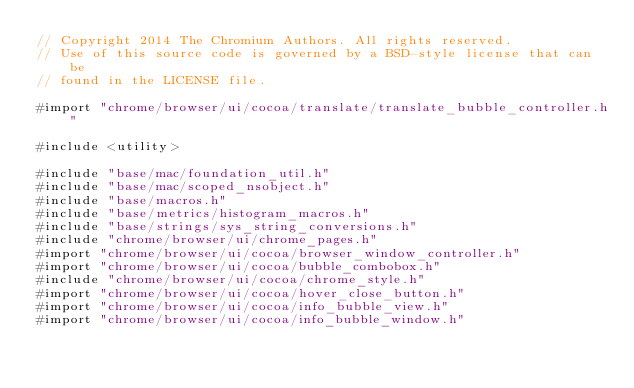<code> <loc_0><loc_0><loc_500><loc_500><_ObjectiveC_>// Copyright 2014 The Chromium Authors. All rights reserved.
// Use of this source code is governed by a BSD-style license that can be
// found in the LICENSE file.

#import "chrome/browser/ui/cocoa/translate/translate_bubble_controller.h"

#include <utility>

#include "base/mac/foundation_util.h"
#include "base/mac/scoped_nsobject.h"
#include "base/macros.h"
#include "base/metrics/histogram_macros.h"
#include "base/strings/sys_string_conversions.h"
#include "chrome/browser/ui/chrome_pages.h"
#import "chrome/browser/ui/cocoa/browser_window_controller.h"
#import "chrome/browser/ui/cocoa/bubble_combobox.h"
#include "chrome/browser/ui/cocoa/chrome_style.h"
#import "chrome/browser/ui/cocoa/hover_close_button.h"
#import "chrome/browser/ui/cocoa/info_bubble_view.h"
#import "chrome/browser/ui/cocoa/info_bubble_window.h"</code> 